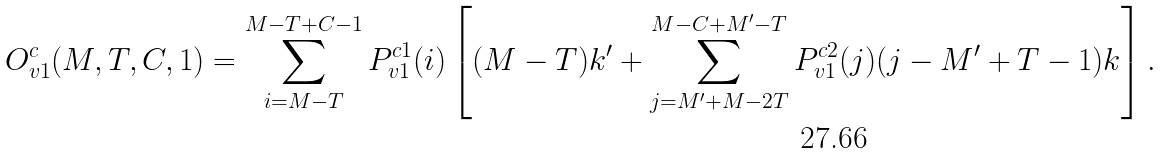<formula> <loc_0><loc_0><loc_500><loc_500>O _ { v 1 } ^ { c } ( M , T , C , 1 ) = \sum _ { i = M - T } ^ { M - T + C - 1 } P _ { v 1 } ^ { c 1 } ( i ) \left [ ( M - T ) k ^ { \prime } + \sum _ { j = M ^ { \prime } + M - 2 T } ^ { M - C + M ^ { \prime } - T } P _ { v 1 } ^ { c 2 } ( j ) ( j - M ^ { \prime } + T - 1 ) k \right ] .</formula> 